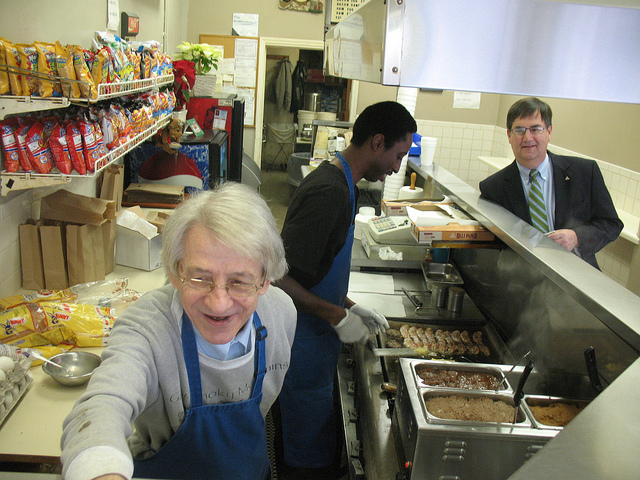<image>What is roasting in the oven behind the people? I don't know what is roasting in the oven behind the people, it could be anything like sandwich, ham, chicken, or even bread. What is roasting in the oven behind the people? I am not sure what is roasting in the oven behind the people. It can be seen sandwich, ham, chicken, soup, bread or bacon. 